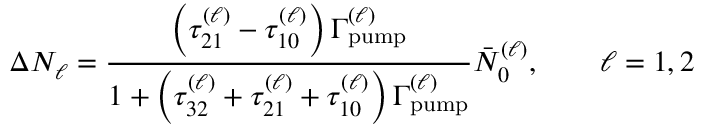<formula> <loc_0><loc_0><loc_500><loc_500>\Delta N _ { \ell } = \frac { \left ( \tau _ { 2 1 } ^ { ( \ell ) } - \tau _ { 1 0 } ^ { ( \ell ) } \right ) \Gamma _ { p u m p } ^ { ( \ell ) } } { 1 + \left ( \tau _ { 3 2 } ^ { ( \ell ) } + \tau _ { 2 1 } ^ { ( \ell ) } + \tau _ { 1 0 } ^ { ( \ell ) } \right ) \Gamma _ { p u m p } ^ { ( \ell ) } } \bar { N } _ { 0 } ^ { ( \ell ) } , \quad \ell = 1 , 2</formula> 